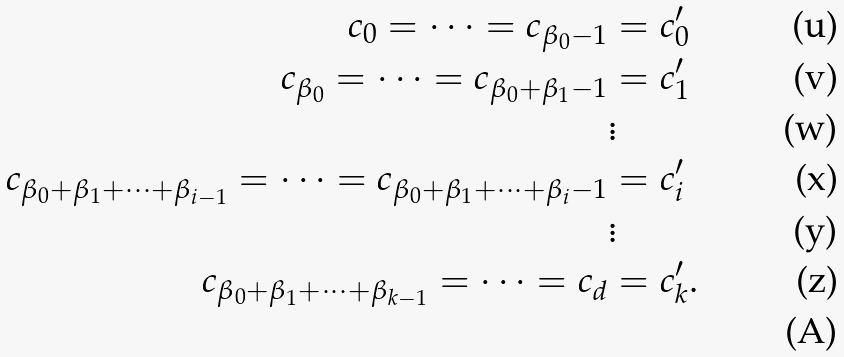Convert formula to latex. <formula><loc_0><loc_0><loc_500><loc_500>c _ { 0 } = \dots = c _ { \beta _ { 0 } - 1 } & = c ^ { \prime } _ { 0 } \\ c _ { \beta _ { 0 } } = \dots = c _ { \beta _ { 0 } + \beta _ { 1 } - 1 } & = c ^ { \prime } _ { 1 } \\ & \vdots \\ c _ { \beta _ { 0 } + \beta _ { 1 } + \dots + \beta _ { i - 1 } } = \dots = c _ { \beta _ { 0 } + \beta _ { 1 } + \dots + \beta _ { i } - 1 } & = c ^ { \prime } _ { i } \\ & \vdots \\ c _ { \beta _ { 0 } + \beta _ { 1 } + \dots + \beta _ { k - 1 } } = \dots = c _ { d } & = c ^ { \prime } _ { k } . \\</formula> 